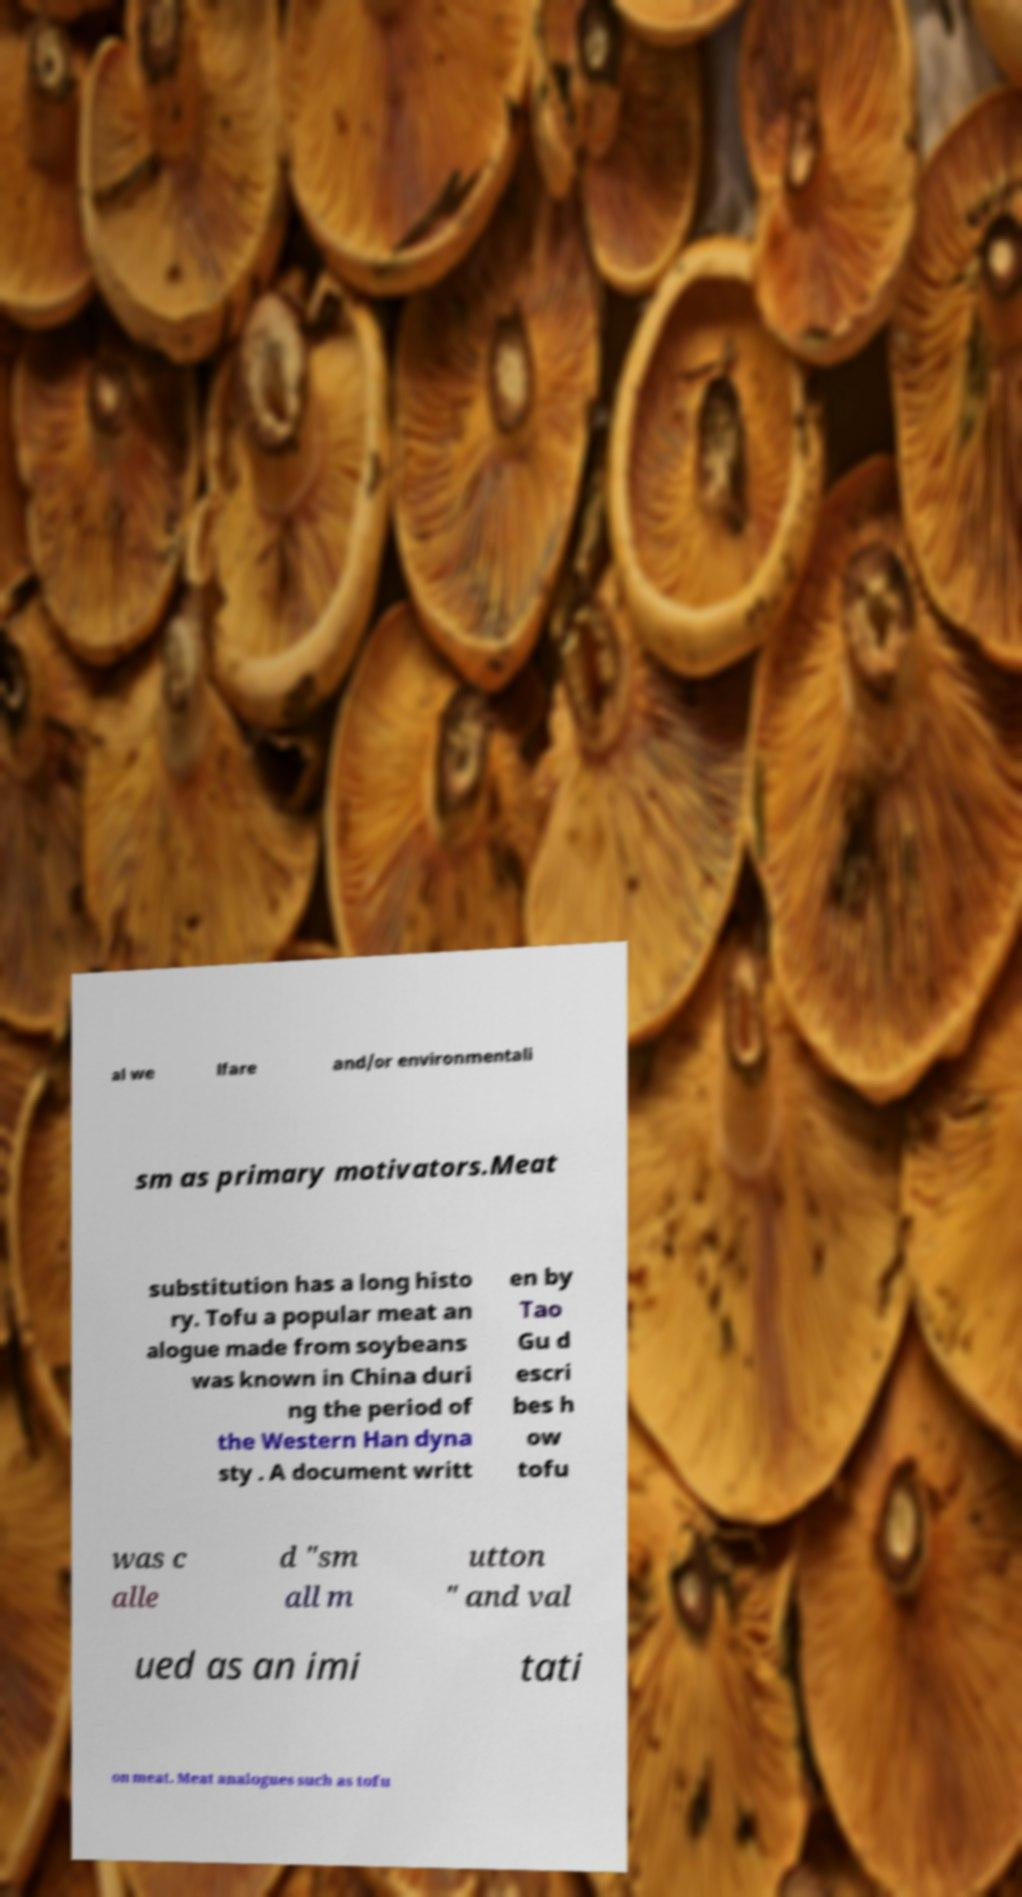Could you assist in decoding the text presented in this image and type it out clearly? al we lfare and/or environmentali sm as primary motivators.Meat substitution has a long histo ry. Tofu a popular meat an alogue made from soybeans was known in China duri ng the period of the Western Han dyna sty . A document writt en by Tao Gu d escri bes h ow tofu was c alle d "sm all m utton " and val ued as an imi tati on meat. Meat analogues such as tofu 